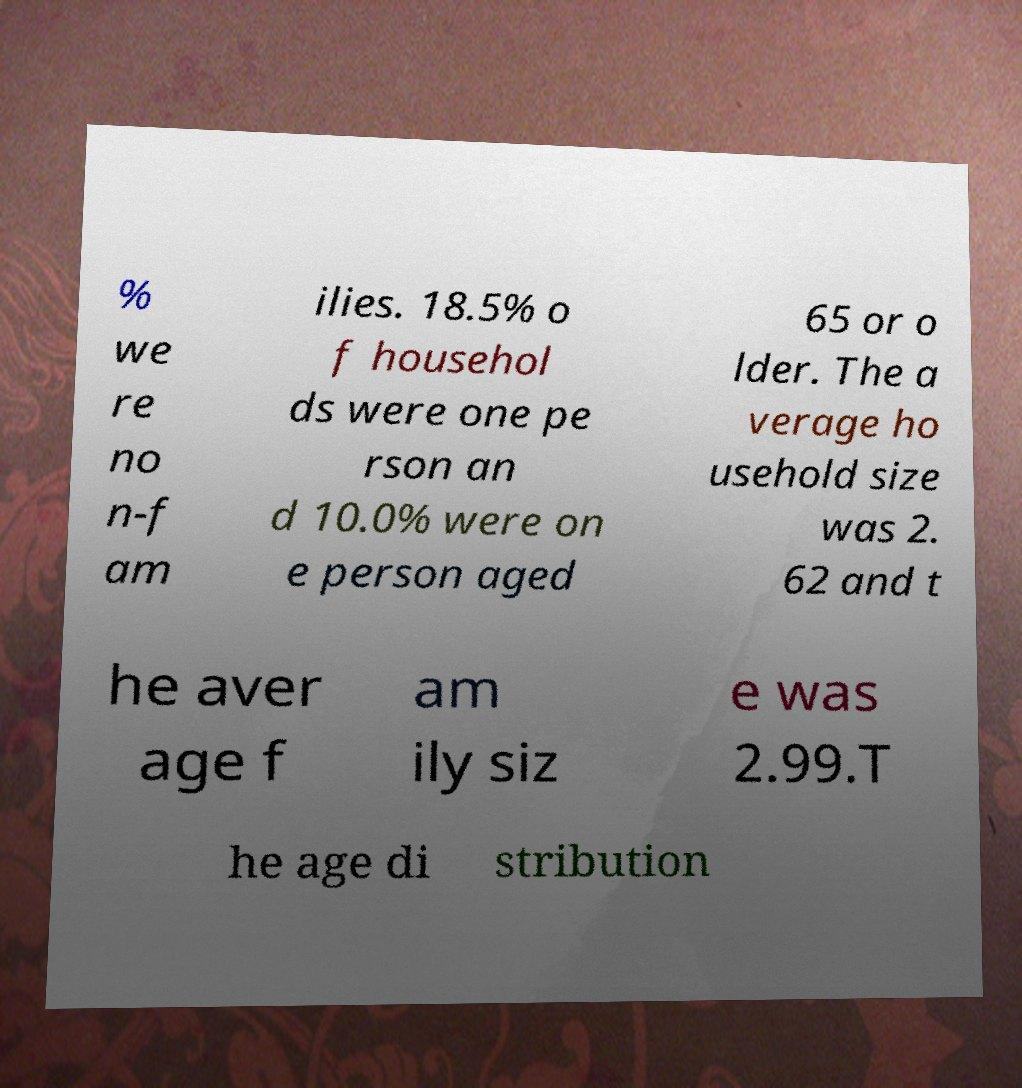Can you accurately transcribe the text from the provided image for me? % we re no n-f am ilies. 18.5% o f househol ds were one pe rson an d 10.0% were on e person aged 65 or o lder. The a verage ho usehold size was 2. 62 and t he aver age f am ily siz e was 2.99.T he age di stribution 